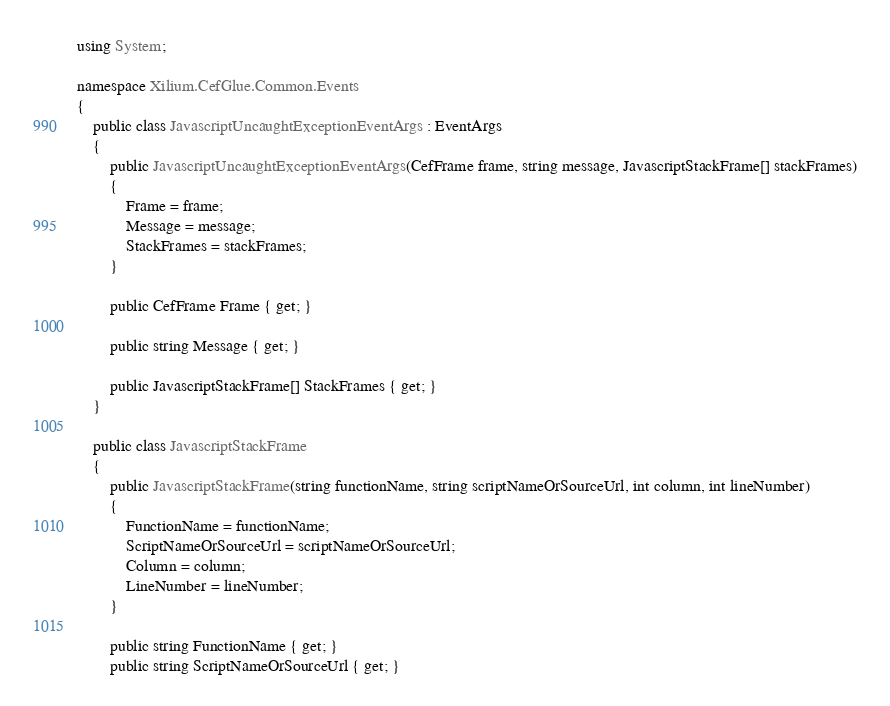<code> <loc_0><loc_0><loc_500><loc_500><_C#_>using System;

namespace Xilium.CefGlue.Common.Events
{
    public class JavascriptUncaughtExceptionEventArgs : EventArgs
	{
        public JavascriptUncaughtExceptionEventArgs(CefFrame frame, string message, JavascriptStackFrame[] stackFrames)
        {
            Frame = frame;
            Message = message;
            StackFrames = stackFrames;
        }

        public CefFrame Frame { get; }

        public string Message { get; }

        public JavascriptStackFrame[] StackFrames { get; }
    }

    public class JavascriptStackFrame
    {
        public JavascriptStackFrame(string functionName, string scriptNameOrSourceUrl, int column, int lineNumber)
        {
            FunctionName = functionName;
            ScriptNameOrSourceUrl = scriptNameOrSourceUrl;
            Column = column;
            LineNumber = lineNumber;
        }

        public string FunctionName { get; }
        public string ScriptNameOrSourceUrl { get; }</code> 